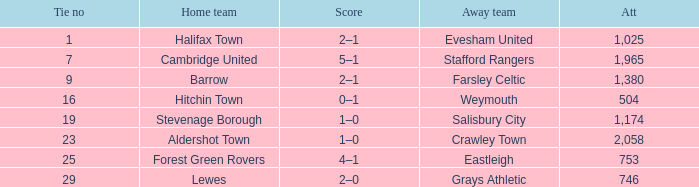What is the highest attendance for games with stevenage borough at home? 1174.0. 